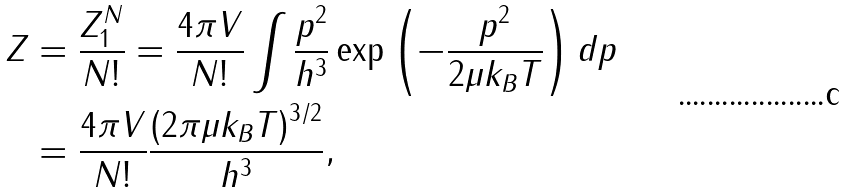Convert formula to latex. <formula><loc_0><loc_0><loc_500><loc_500>Z & = \frac { Z _ { 1 } ^ { N } } { N ! } = \frac { 4 \pi V } { N ! } \int { \frac { p ^ { 2 } } { h ^ { 3 } } \exp \left ( { - \frac { p ^ { 2 } } { { 2 \mu { k _ { B } } T } } } \right ) d p } \\ & = \frac { 4 \pi V } { N ! } \frac { { { { \left ( { 2 \pi \mu { k _ { B } } T } \right ) } ^ { 3 / 2 } } } } { h ^ { 3 } } ,</formula> 